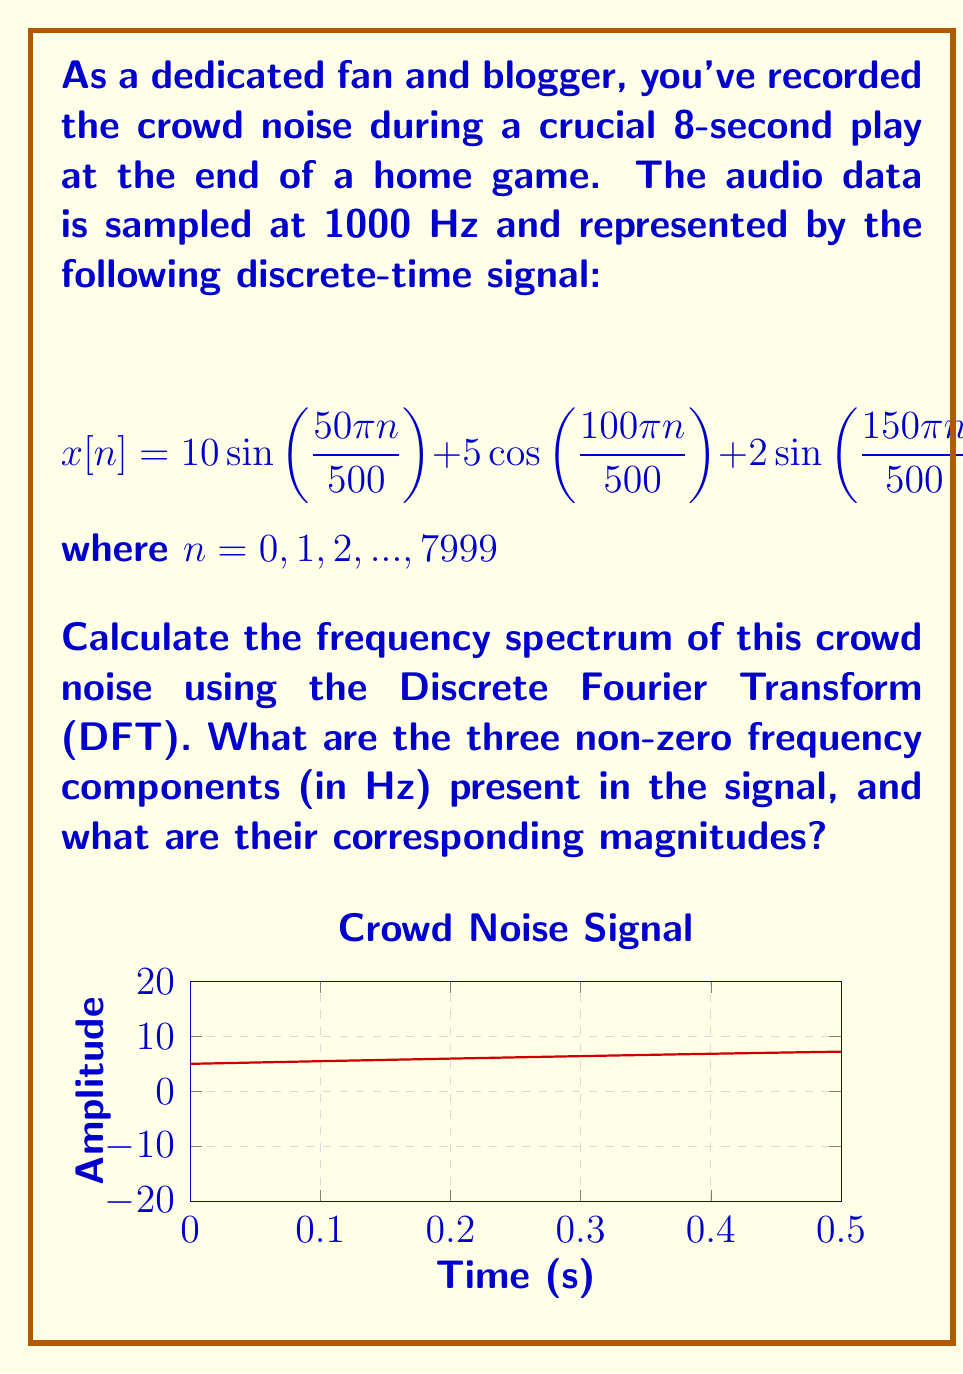Show me your answer to this math problem. Let's approach this step-by-step:

1) First, we need to identify the frequencies in the signal. The general form of a sinusoidal component is $\sin(2\pi f t)$ or $\cos(2\pi f t)$, where $f$ is the frequency.

2) In our discrete-time signal, we have:
   $50\pi n/500 = 2\pi (25n/500)$
   $100\pi n/500 = 2\pi (50n/500)$
   $150\pi n/500 = 2\pi (75n/500)$

3) The sampling frequency $f_s = 1000$ Hz. So, the actual frequencies are:
   $f_1 = 25 * (1000/500) = 50$ Hz
   $f_2 = 50 * (1000/500) = 100$ Hz
   $f_3 = 75 * (1000/500) = 150$ Hz

4) Now, for the magnitudes. In the DFT, the magnitude of a sinusoidal component is half of its amplitude in the time domain (except for DC component).

5) The amplitudes in the time domain are:
   For 50 Hz: 10
   For 100 Hz: 5
   For 150 Hz: 2

6) Therefore, the magnitudes in the frequency domain will be:
   For 50 Hz: 10/2 = 5
   For 100 Hz: 5/2 = 2.5
   For 150 Hz: 2/2 = 1

Note: The cosine component at 100 Hz is treated the same way as sine components in terms of DFT magnitude calculation.
Answer: 50 Hz (magnitude 5), 100 Hz (magnitude 2.5), 150 Hz (magnitude 1) 